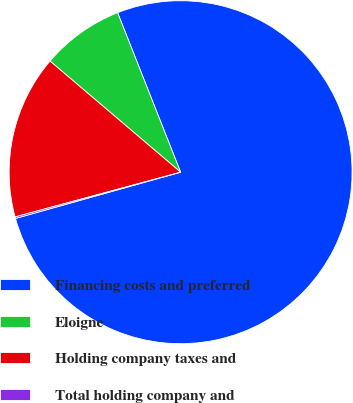<chart> <loc_0><loc_0><loc_500><loc_500><pie_chart><fcel>Financing costs and preferred<fcel>Eloigne<fcel>Holding company taxes and<fcel>Total holding company and<nl><fcel>76.63%<fcel>7.79%<fcel>15.42%<fcel>0.15%<nl></chart> 